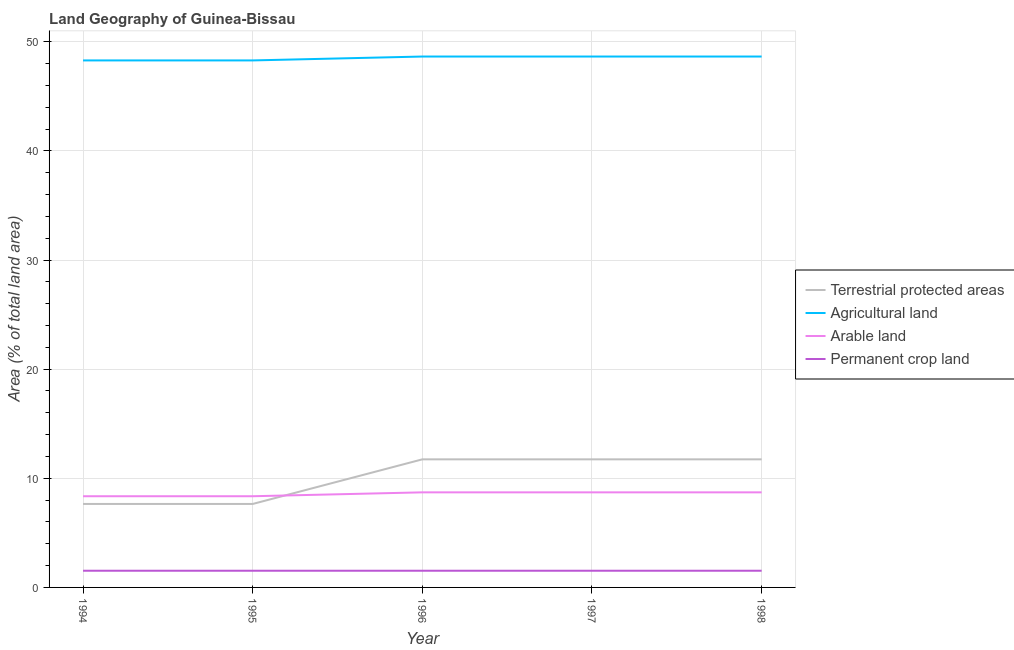Is the number of lines equal to the number of legend labels?
Give a very brief answer. Yes. What is the percentage of area under permanent crop land in 1995?
Your answer should be compact. 1.53. Across all years, what is the maximum percentage of area under permanent crop land?
Keep it short and to the point. 1.53. Across all years, what is the minimum percentage of area under agricultural land?
Offer a terse response. 48.29. In which year was the percentage of land under terrestrial protection minimum?
Give a very brief answer. 1994. What is the total percentage of land under terrestrial protection in the graph?
Offer a terse response. 50.51. What is the difference between the percentage of area under arable land in 1997 and the percentage of area under permanent crop land in 1998?
Provide a succinct answer. 7.18. What is the average percentage of area under arable land per year?
Offer a very short reply. 8.57. In the year 1998, what is the difference between the percentage of area under permanent crop land and percentage of area under agricultural land?
Ensure brevity in your answer.  -47.12. In how many years, is the percentage of area under permanent crop land greater than 18 %?
Offer a terse response. 0. What is the ratio of the percentage of land under terrestrial protection in 1994 to that in 1996?
Your answer should be very brief. 0.65. Is the percentage of area under permanent crop land in 1996 less than that in 1997?
Your response must be concise. No. What is the difference between the highest and the second highest percentage of area under agricultural land?
Provide a succinct answer. 0. What is the difference between the highest and the lowest percentage of land under terrestrial protection?
Provide a short and direct response. 4.09. Is the sum of the percentage of area under arable land in 1995 and 1997 greater than the maximum percentage of area under agricultural land across all years?
Give a very brief answer. No. Does the percentage of area under arable land monotonically increase over the years?
Provide a succinct answer. No. Is the percentage of area under agricultural land strictly greater than the percentage of area under arable land over the years?
Give a very brief answer. Yes. How many lines are there?
Make the answer very short. 4. What is the difference between two consecutive major ticks on the Y-axis?
Offer a very short reply. 10. Does the graph contain any zero values?
Ensure brevity in your answer.  No. Where does the legend appear in the graph?
Give a very brief answer. Center right. How many legend labels are there?
Provide a succinct answer. 4. What is the title of the graph?
Give a very brief answer. Land Geography of Guinea-Bissau. What is the label or title of the X-axis?
Your answer should be very brief. Year. What is the label or title of the Y-axis?
Provide a succinct answer. Area (% of total land area). What is the Area (% of total land area) of Terrestrial protected areas in 1994?
Keep it short and to the point. 7.65. What is the Area (% of total land area) in Agricultural land in 1994?
Your answer should be compact. 48.29. What is the Area (% of total land area) in Arable land in 1994?
Make the answer very short. 8.36. What is the Area (% of total land area) of Permanent crop land in 1994?
Keep it short and to the point. 1.53. What is the Area (% of total land area) in Terrestrial protected areas in 1995?
Make the answer very short. 7.65. What is the Area (% of total land area) in Agricultural land in 1995?
Keep it short and to the point. 48.29. What is the Area (% of total land area) of Arable land in 1995?
Ensure brevity in your answer.  8.36. What is the Area (% of total land area) in Permanent crop land in 1995?
Give a very brief answer. 1.53. What is the Area (% of total land area) of Terrestrial protected areas in 1996?
Give a very brief answer. 11.74. What is the Area (% of total land area) in Agricultural land in 1996?
Offer a terse response. 48.65. What is the Area (% of total land area) in Arable land in 1996?
Keep it short and to the point. 8.71. What is the Area (% of total land area) of Permanent crop land in 1996?
Provide a succinct answer. 1.53. What is the Area (% of total land area) in Terrestrial protected areas in 1997?
Offer a very short reply. 11.74. What is the Area (% of total land area) of Agricultural land in 1997?
Provide a succinct answer. 48.65. What is the Area (% of total land area) in Arable land in 1997?
Make the answer very short. 8.71. What is the Area (% of total land area) of Permanent crop land in 1997?
Ensure brevity in your answer.  1.53. What is the Area (% of total land area) of Terrestrial protected areas in 1998?
Provide a short and direct response. 11.74. What is the Area (% of total land area) of Agricultural land in 1998?
Keep it short and to the point. 48.65. What is the Area (% of total land area) of Arable land in 1998?
Your response must be concise. 8.71. What is the Area (% of total land area) in Permanent crop land in 1998?
Make the answer very short. 1.53. Across all years, what is the maximum Area (% of total land area) of Terrestrial protected areas?
Your answer should be compact. 11.74. Across all years, what is the maximum Area (% of total land area) in Agricultural land?
Your answer should be very brief. 48.65. Across all years, what is the maximum Area (% of total land area) of Arable land?
Your answer should be compact. 8.71. Across all years, what is the maximum Area (% of total land area) of Permanent crop land?
Keep it short and to the point. 1.53. Across all years, what is the minimum Area (% of total land area) of Terrestrial protected areas?
Offer a very short reply. 7.65. Across all years, what is the minimum Area (% of total land area) of Agricultural land?
Ensure brevity in your answer.  48.29. Across all years, what is the minimum Area (% of total land area) in Arable land?
Ensure brevity in your answer.  8.36. Across all years, what is the minimum Area (% of total land area) of Permanent crop land?
Offer a terse response. 1.53. What is the total Area (% of total land area) of Terrestrial protected areas in the graph?
Give a very brief answer. 50.51. What is the total Area (% of total land area) in Agricultural land in the graph?
Provide a short and direct response. 242.53. What is the total Area (% of total land area) in Arable land in the graph?
Offer a very short reply. 42.85. What is the total Area (% of total land area) of Permanent crop land in the graph?
Give a very brief answer. 7.65. What is the difference between the Area (% of total land area) of Terrestrial protected areas in 1994 and that in 1995?
Offer a terse response. 0. What is the difference between the Area (% of total land area) in Agricultural land in 1994 and that in 1995?
Offer a very short reply. 0. What is the difference between the Area (% of total land area) in Permanent crop land in 1994 and that in 1995?
Your response must be concise. 0. What is the difference between the Area (% of total land area) of Terrestrial protected areas in 1994 and that in 1996?
Your response must be concise. -4.09. What is the difference between the Area (% of total land area) of Agricultural land in 1994 and that in 1996?
Make the answer very short. -0.36. What is the difference between the Area (% of total land area) of Arable land in 1994 and that in 1996?
Keep it short and to the point. -0.36. What is the difference between the Area (% of total land area) in Permanent crop land in 1994 and that in 1996?
Your response must be concise. 0. What is the difference between the Area (% of total land area) of Terrestrial protected areas in 1994 and that in 1997?
Your answer should be very brief. -4.09. What is the difference between the Area (% of total land area) in Agricultural land in 1994 and that in 1997?
Offer a terse response. -0.36. What is the difference between the Area (% of total land area) in Arable land in 1994 and that in 1997?
Keep it short and to the point. -0.36. What is the difference between the Area (% of total land area) of Permanent crop land in 1994 and that in 1997?
Give a very brief answer. 0. What is the difference between the Area (% of total land area) of Terrestrial protected areas in 1994 and that in 1998?
Your response must be concise. -4.09. What is the difference between the Area (% of total land area) in Agricultural land in 1994 and that in 1998?
Keep it short and to the point. -0.36. What is the difference between the Area (% of total land area) in Arable land in 1994 and that in 1998?
Ensure brevity in your answer.  -0.36. What is the difference between the Area (% of total land area) of Terrestrial protected areas in 1995 and that in 1996?
Your response must be concise. -4.09. What is the difference between the Area (% of total land area) of Agricultural land in 1995 and that in 1996?
Provide a short and direct response. -0.36. What is the difference between the Area (% of total land area) in Arable land in 1995 and that in 1996?
Your answer should be very brief. -0.36. What is the difference between the Area (% of total land area) in Terrestrial protected areas in 1995 and that in 1997?
Keep it short and to the point. -4.09. What is the difference between the Area (% of total land area) in Agricultural land in 1995 and that in 1997?
Your answer should be compact. -0.36. What is the difference between the Area (% of total land area) of Arable land in 1995 and that in 1997?
Your answer should be compact. -0.36. What is the difference between the Area (% of total land area) of Terrestrial protected areas in 1995 and that in 1998?
Your response must be concise. -4.09. What is the difference between the Area (% of total land area) in Agricultural land in 1995 and that in 1998?
Your answer should be very brief. -0.36. What is the difference between the Area (% of total land area) in Arable land in 1995 and that in 1998?
Make the answer very short. -0.36. What is the difference between the Area (% of total land area) in Permanent crop land in 1995 and that in 1998?
Your answer should be very brief. 0. What is the difference between the Area (% of total land area) of Terrestrial protected areas in 1996 and that in 1997?
Your response must be concise. 0. What is the difference between the Area (% of total land area) in Agricultural land in 1996 and that in 1997?
Your answer should be very brief. 0. What is the difference between the Area (% of total land area) in Permanent crop land in 1996 and that in 1997?
Your answer should be compact. 0. What is the difference between the Area (% of total land area) of Arable land in 1996 and that in 1998?
Provide a succinct answer. 0. What is the difference between the Area (% of total land area) of Agricultural land in 1997 and that in 1998?
Your answer should be compact. 0. What is the difference between the Area (% of total land area) of Arable land in 1997 and that in 1998?
Make the answer very short. 0. What is the difference between the Area (% of total land area) in Permanent crop land in 1997 and that in 1998?
Keep it short and to the point. 0. What is the difference between the Area (% of total land area) in Terrestrial protected areas in 1994 and the Area (% of total land area) in Agricultural land in 1995?
Your answer should be very brief. -40.64. What is the difference between the Area (% of total land area) in Terrestrial protected areas in 1994 and the Area (% of total land area) in Arable land in 1995?
Offer a terse response. -0.71. What is the difference between the Area (% of total land area) in Terrestrial protected areas in 1994 and the Area (% of total land area) in Permanent crop land in 1995?
Make the answer very short. 6.12. What is the difference between the Area (% of total land area) of Agricultural land in 1994 and the Area (% of total land area) of Arable land in 1995?
Your response must be concise. 39.94. What is the difference between the Area (% of total land area) in Agricultural land in 1994 and the Area (% of total land area) in Permanent crop land in 1995?
Give a very brief answer. 46.76. What is the difference between the Area (% of total land area) in Arable land in 1994 and the Area (% of total land area) in Permanent crop land in 1995?
Provide a succinct answer. 6.83. What is the difference between the Area (% of total land area) of Terrestrial protected areas in 1994 and the Area (% of total land area) of Agricultural land in 1996?
Your answer should be compact. -41. What is the difference between the Area (% of total land area) in Terrestrial protected areas in 1994 and the Area (% of total land area) in Arable land in 1996?
Give a very brief answer. -1.06. What is the difference between the Area (% of total land area) of Terrestrial protected areas in 1994 and the Area (% of total land area) of Permanent crop land in 1996?
Ensure brevity in your answer.  6.12. What is the difference between the Area (% of total land area) in Agricultural land in 1994 and the Area (% of total land area) in Arable land in 1996?
Ensure brevity in your answer.  39.58. What is the difference between the Area (% of total land area) in Agricultural land in 1994 and the Area (% of total land area) in Permanent crop land in 1996?
Your response must be concise. 46.76. What is the difference between the Area (% of total land area) in Arable land in 1994 and the Area (% of total land area) in Permanent crop land in 1996?
Ensure brevity in your answer.  6.83. What is the difference between the Area (% of total land area) in Terrestrial protected areas in 1994 and the Area (% of total land area) in Agricultural land in 1997?
Offer a terse response. -41. What is the difference between the Area (% of total land area) in Terrestrial protected areas in 1994 and the Area (% of total land area) in Arable land in 1997?
Provide a succinct answer. -1.06. What is the difference between the Area (% of total land area) of Terrestrial protected areas in 1994 and the Area (% of total land area) of Permanent crop land in 1997?
Make the answer very short. 6.12. What is the difference between the Area (% of total land area) of Agricultural land in 1994 and the Area (% of total land area) of Arable land in 1997?
Your answer should be very brief. 39.58. What is the difference between the Area (% of total land area) in Agricultural land in 1994 and the Area (% of total land area) in Permanent crop land in 1997?
Offer a very short reply. 46.76. What is the difference between the Area (% of total land area) of Arable land in 1994 and the Area (% of total land area) of Permanent crop land in 1997?
Keep it short and to the point. 6.83. What is the difference between the Area (% of total land area) in Terrestrial protected areas in 1994 and the Area (% of total land area) in Agricultural land in 1998?
Keep it short and to the point. -41. What is the difference between the Area (% of total land area) in Terrestrial protected areas in 1994 and the Area (% of total land area) in Arable land in 1998?
Make the answer very short. -1.06. What is the difference between the Area (% of total land area) of Terrestrial protected areas in 1994 and the Area (% of total land area) of Permanent crop land in 1998?
Provide a short and direct response. 6.12. What is the difference between the Area (% of total land area) of Agricultural land in 1994 and the Area (% of total land area) of Arable land in 1998?
Ensure brevity in your answer.  39.58. What is the difference between the Area (% of total land area) of Agricultural land in 1994 and the Area (% of total land area) of Permanent crop land in 1998?
Provide a succinct answer. 46.76. What is the difference between the Area (% of total land area) in Arable land in 1994 and the Area (% of total land area) in Permanent crop land in 1998?
Provide a succinct answer. 6.83. What is the difference between the Area (% of total land area) in Terrestrial protected areas in 1995 and the Area (% of total land area) in Agricultural land in 1996?
Provide a short and direct response. -41. What is the difference between the Area (% of total land area) of Terrestrial protected areas in 1995 and the Area (% of total land area) of Arable land in 1996?
Ensure brevity in your answer.  -1.06. What is the difference between the Area (% of total land area) in Terrestrial protected areas in 1995 and the Area (% of total land area) in Permanent crop land in 1996?
Your answer should be compact. 6.12. What is the difference between the Area (% of total land area) in Agricultural land in 1995 and the Area (% of total land area) in Arable land in 1996?
Provide a succinct answer. 39.58. What is the difference between the Area (% of total land area) of Agricultural land in 1995 and the Area (% of total land area) of Permanent crop land in 1996?
Make the answer very short. 46.76. What is the difference between the Area (% of total land area) of Arable land in 1995 and the Area (% of total land area) of Permanent crop land in 1996?
Keep it short and to the point. 6.83. What is the difference between the Area (% of total land area) in Terrestrial protected areas in 1995 and the Area (% of total land area) in Agricultural land in 1997?
Give a very brief answer. -41. What is the difference between the Area (% of total land area) of Terrestrial protected areas in 1995 and the Area (% of total land area) of Arable land in 1997?
Ensure brevity in your answer.  -1.06. What is the difference between the Area (% of total land area) in Terrestrial protected areas in 1995 and the Area (% of total land area) in Permanent crop land in 1997?
Offer a terse response. 6.12. What is the difference between the Area (% of total land area) in Agricultural land in 1995 and the Area (% of total land area) in Arable land in 1997?
Offer a terse response. 39.58. What is the difference between the Area (% of total land area) in Agricultural land in 1995 and the Area (% of total land area) in Permanent crop land in 1997?
Ensure brevity in your answer.  46.76. What is the difference between the Area (% of total land area) of Arable land in 1995 and the Area (% of total land area) of Permanent crop land in 1997?
Keep it short and to the point. 6.83. What is the difference between the Area (% of total land area) in Terrestrial protected areas in 1995 and the Area (% of total land area) in Agricultural land in 1998?
Your answer should be compact. -41. What is the difference between the Area (% of total land area) in Terrestrial protected areas in 1995 and the Area (% of total land area) in Arable land in 1998?
Ensure brevity in your answer.  -1.06. What is the difference between the Area (% of total land area) in Terrestrial protected areas in 1995 and the Area (% of total land area) in Permanent crop land in 1998?
Make the answer very short. 6.12. What is the difference between the Area (% of total land area) of Agricultural land in 1995 and the Area (% of total land area) of Arable land in 1998?
Give a very brief answer. 39.58. What is the difference between the Area (% of total land area) of Agricultural land in 1995 and the Area (% of total land area) of Permanent crop land in 1998?
Give a very brief answer. 46.76. What is the difference between the Area (% of total land area) of Arable land in 1995 and the Area (% of total land area) of Permanent crop land in 1998?
Keep it short and to the point. 6.83. What is the difference between the Area (% of total land area) of Terrestrial protected areas in 1996 and the Area (% of total land area) of Agricultural land in 1997?
Your answer should be compact. -36.91. What is the difference between the Area (% of total land area) of Terrestrial protected areas in 1996 and the Area (% of total land area) of Arable land in 1997?
Your answer should be very brief. 3.02. What is the difference between the Area (% of total land area) of Terrestrial protected areas in 1996 and the Area (% of total land area) of Permanent crop land in 1997?
Your response must be concise. 10.21. What is the difference between the Area (% of total land area) in Agricultural land in 1996 and the Area (% of total land area) in Arable land in 1997?
Keep it short and to the point. 39.94. What is the difference between the Area (% of total land area) of Agricultural land in 1996 and the Area (% of total land area) of Permanent crop land in 1997?
Your answer should be very brief. 47.12. What is the difference between the Area (% of total land area) of Arable land in 1996 and the Area (% of total land area) of Permanent crop land in 1997?
Provide a succinct answer. 7.18. What is the difference between the Area (% of total land area) in Terrestrial protected areas in 1996 and the Area (% of total land area) in Agricultural land in 1998?
Your answer should be very brief. -36.91. What is the difference between the Area (% of total land area) of Terrestrial protected areas in 1996 and the Area (% of total land area) of Arable land in 1998?
Provide a short and direct response. 3.02. What is the difference between the Area (% of total land area) in Terrestrial protected areas in 1996 and the Area (% of total land area) in Permanent crop land in 1998?
Provide a succinct answer. 10.21. What is the difference between the Area (% of total land area) of Agricultural land in 1996 and the Area (% of total land area) of Arable land in 1998?
Your answer should be very brief. 39.94. What is the difference between the Area (% of total land area) in Agricultural land in 1996 and the Area (% of total land area) in Permanent crop land in 1998?
Your response must be concise. 47.12. What is the difference between the Area (% of total land area) in Arable land in 1996 and the Area (% of total land area) in Permanent crop land in 1998?
Ensure brevity in your answer.  7.18. What is the difference between the Area (% of total land area) in Terrestrial protected areas in 1997 and the Area (% of total land area) in Agricultural land in 1998?
Offer a terse response. -36.91. What is the difference between the Area (% of total land area) in Terrestrial protected areas in 1997 and the Area (% of total land area) in Arable land in 1998?
Provide a short and direct response. 3.02. What is the difference between the Area (% of total land area) in Terrestrial protected areas in 1997 and the Area (% of total land area) in Permanent crop land in 1998?
Make the answer very short. 10.21. What is the difference between the Area (% of total land area) of Agricultural land in 1997 and the Area (% of total land area) of Arable land in 1998?
Ensure brevity in your answer.  39.94. What is the difference between the Area (% of total land area) of Agricultural land in 1997 and the Area (% of total land area) of Permanent crop land in 1998?
Offer a very short reply. 47.12. What is the difference between the Area (% of total land area) of Arable land in 1997 and the Area (% of total land area) of Permanent crop land in 1998?
Ensure brevity in your answer.  7.18. What is the average Area (% of total land area) of Terrestrial protected areas per year?
Provide a succinct answer. 10.1. What is the average Area (% of total land area) in Agricultural land per year?
Provide a succinct answer. 48.51. What is the average Area (% of total land area) of Arable land per year?
Give a very brief answer. 8.57. What is the average Area (% of total land area) of Permanent crop land per year?
Provide a succinct answer. 1.53. In the year 1994, what is the difference between the Area (% of total land area) in Terrestrial protected areas and Area (% of total land area) in Agricultural land?
Your response must be concise. -40.64. In the year 1994, what is the difference between the Area (% of total land area) of Terrestrial protected areas and Area (% of total land area) of Arable land?
Offer a very short reply. -0.71. In the year 1994, what is the difference between the Area (% of total land area) in Terrestrial protected areas and Area (% of total land area) in Permanent crop land?
Ensure brevity in your answer.  6.12. In the year 1994, what is the difference between the Area (% of total land area) of Agricultural land and Area (% of total land area) of Arable land?
Keep it short and to the point. 39.94. In the year 1994, what is the difference between the Area (% of total land area) in Agricultural land and Area (% of total land area) in Permanent crop land?
Give a very brief answer. 46.76. In the year 1994, what is the difference between the Area (% of total land area) in Arable land and Area (% of total land area) in Permanent crop land?
Your answer should be very brief. 6.83. In the year 1995, what is the difference between the Area (% of total land area) of Terrestrial protected areas and Area (% of total land area) of Agricultural land?
Ensure brevity in your answer.  -40.64. In the year 1995, what is the difference between the Area (% of total land area) of Terrestrial protected areas and Area (% of total land area) of Arable land?
Make the answer very short. -0.71. In the year 1995, what is the difference between the Area (% of total land area) of Terrestrial protected areas and Area (% of total land area) of Permanent crop land?
Offer a terse response. 6.12. In the year 1995, what is the difference between the Area (% of total land area) of Agricultural land and Area (% of total land area) of Arable land?
Your answer should be compact. 39.94. In the year 1995, what is the difference between the Area (% of total land area) in Agricultural land and Area (% of total land area) in Permanent crop land?
Offer a very short reply. 46.76. In the year 1995, what is the difference between the Area (% of total land area) in Arable land and Area (% of total land area) in Permanent crop land?
Give a very brief answer. 6.83. In the year 1996, what is the difference between the Area (% of total land area) of Terrestrial protected areas and Area (% of total land area) of Agricultural land?
Provide a short and direct response. -36.91. In the year 1996, what is the difference between the Area (% of total land area) of Terrestrial protected areas and Area (% of total land area) of Arable land?
Your answer should be compact. 3.02. In the year 1996, what is the difference between the Area (% of total land area) of Terrestrial protected areas and Area (% of total land area) of Permanent crop land?
Ensure brevity in your answer.  10.21. In the year 1996, what is the difference between the Area (% of total land area) in Agricultural land and Area (% of total land area) in Arable land?
Your response must be concise. 39.94. In the year 1996, what is the difference between the Area (% of total land area) in Agricultural land and Area (% of total land area) in Permanent crop land?
Make the answer very short. 47.12. In the year 1996, what is the difference between the Area (% of total land area) in Arable land and Area (% of total land area) in Permanent crop land?
Keep it short and to the point. 7.18. In the year 1997, what is the difference between the Area (% of total land area) of Terrestrial protected areas and Area (% of total land area) of Agricultural land?
Offer a very short reply. -36.91. In the year 1997, what is the difference between the Area (% of total land area) in Terrestrial protected areas and Area (% of total land area) in Arable land?
Ensure brevity in your answer.  3.02. In the year 1997, what is the difference between the Area (% of total land area) in Terrestrial protected areas and Area (% of total land area) in Permanent crop land?
Your response must be concise. 10.21. In the year 1997, what is the difference between the Area (% of total land area) in Agricultural land and Area (% of total land area) in Arable land?
Make the answer very short. 39.94. In the year 1997, what is the difference between the Area (% of total land area) in Agricultural land and Area (% of total land area) in Permanent crop land?
Provide a short and direct response. 47.12. In the year 1997, what is the difference between the Area (% of total land area) of Arable land and Area (% of total land area) of Permanent crop land?
Ensure brevity in your answer.  7.18. In the year 1998, what is the difference between the Area (% of total land area) in Terrestrial protected areas and Area (% of total land area) in Agricultural land?
Provide a short and direct response. -36.91. In the year 1998, what is the difference between the Area (% of total land area) of Terrestrial protected areas and Area (% of total land area) of Arable land?
Give a very brief answer. 3.02. In the year 1998, what is the difference between the Area (% of total land area) of Terrestrial protected areas and Area (% of total land area) of Permanent crop land?
Offer a terse response. 10.21. In the year 1998, what is the difference between the Area (% of total land area) of Agricultural land and Area (% of total land area) of Arable land?
Offer a terse response. 39.94. In the year 1998, what is the difference between the Area (% of total land area) of Agricultural land and Area (% of total land area) of Permanent crop land?
Make the answer very short. 47.12. In the year 1998, what is the difference between the Area (% of total land area) of Arable land and Area (% of total land area) of Permanent crop land?
Keep it short and to the point. 7.18. What is the ratio of the Area (% of total land area) of Agricultural land in 1994 to that in 1995?
Offer a terse response. 1. What is the ratio of the Area (% of total land area) of Permanent crop land in 1994 to that in 1995?
Provide a short and direct response. 1. What is the ratio of the Area (% of total land area) in Terrestrial protected areas in 1994 to that in 1996?
Your answer should be compact. 0.65. What is the ratio of the Area (% of total land area) of Arable land in 1994 to that in 1996?
Offer a terse response. 0.96. What is the ratio of the Area (% of total land area) in Permanent crop land in 1994 to that in 1996?
Your response must be concise. 1. What is the ratio of the Area (% of total land area) in Terrestrial protected areas in 1994 to that in 1997?
Your answer should be compact. 0.65. What is the ratio of the Area (% of total land area) of Arable land in 1994 to that in 1997?
Make the answer very short. 0.96. What is the ratio of the Area (% of total land area) in Terrestrial protected areas in 1994 to that in 1998?
Provide a succinct answer. 0.65. What is the ratio of the Area (% of total land area) of Agricultural land in 1994 to that in 1998?
Keep it short and to the point. 0.99. What is the ratio of the Area (% of total land area) in Arable land in 1994 to that in 1998?
Offer a very short reply. 0.96. What is the ratio of the Area (% of total land area) in Permanent crop land in 1994 to that in 1998?
Your response must be concise. 1. What is the ratio of the Area (% of total land area) in Terrestrial protected areas in 1995 to that in 1996?
Your answer should be compact. 0.65. What is the ratio of the Area (% of total land area) of Agricultural land in 1995 to that in 1996?
Your answer should be very brief. 0.99. What is the ratio of the Area (% of total land area) in Arable land in 1995 to that in 1996?
Your answer should be compact. 0.96. What is the ratio of the Area (% of total land area) in Terrestrial protected areas in 1995 to that in 1997?
Offer a terse response. 0.65. What is the ratio of the Area (% of total land area) in Arable land in 1995 to that in 1997?
Make the answer very short. 0.96. What is the ratio of the Area (% of total land area) of Terrestrial protected areas in 1995 to that in 1998?
Give a very brief answer. 0.65. What is the ratio of the Area (% of total land area) of Agricultural land in 1995 to that in 1998?
Give a very brief answer. 0.99. What is the ratio of the Area (% of total land area) in Arable land in 1995 to that in 1998?
Offer a very short reply. 0.96. What is the ratio of the Area (% of total land area) of Permanent crop land in 1995 to that in 1998?
Provide a short and direct response. 1. What is the ratio of the Area (% of total land area) of Arable land in 1996 to that in 1997?
Provide a succinct answer. 1. What is the ratio of the Area (% of total land area) in Terrestrial protected areas in 1996 to that in 1998?
Your answer should be very brief. 1. What is the ratio of the Area (% of total land area) in Agricultural land in 1996 to that in 1998?
Ensure brevity in your answer.  1. What is the ratio of the Area (% of total land area) in Arable land in 1996 to that in 1998?
Offer a very short reply. 1. What is the difference between the highest and the second highest Area (% of total land area) of Agricultural land?
Your response must be concise. 0. What is the difference between the highest and the second highest Area (% of total land area) in Arable land?
Make the answer very short. 0. What is the difference between the highest and the lowest Area (% of total land area) in Terrestrial protected areas?
Your answer should be very brief. 4.09. What is the difference between the highest and the lowest Area (% of total land area) in Agricultural land?
Provide a short and direct response. 0.36. What is the difference between the highest and the lowest Area (% of total land area) in Arable land?
Provide a succinct answer. 0.36. What is the difference between the highest and the lowest Area (% of total land area) in Permanent crop land?
Give a very brief answer. 0. 